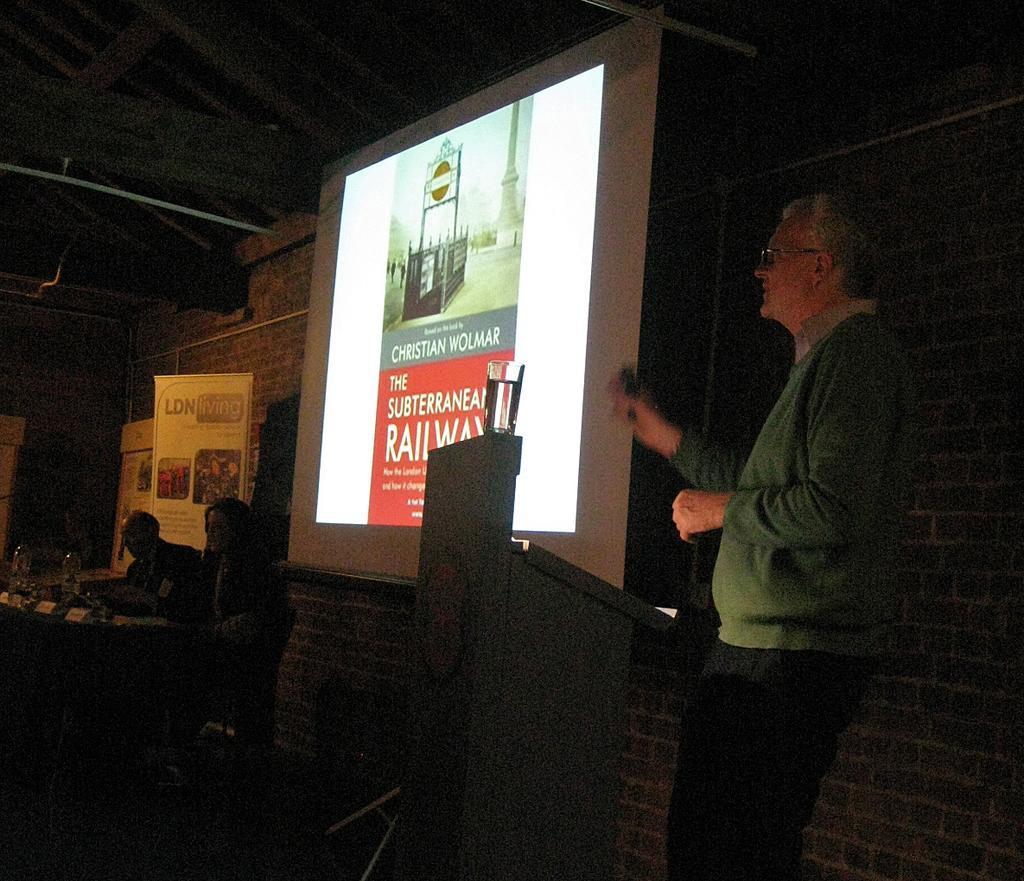How would you summarize this image in a sentence or two? In this picture, there is a man towards the right. He is standing beside the podium. He is wearing a green jacket. In the center, there is a projector screen. At the bottom left, there are two persons sitting beside the table. Behind them, there are banners with some text and pictures. 